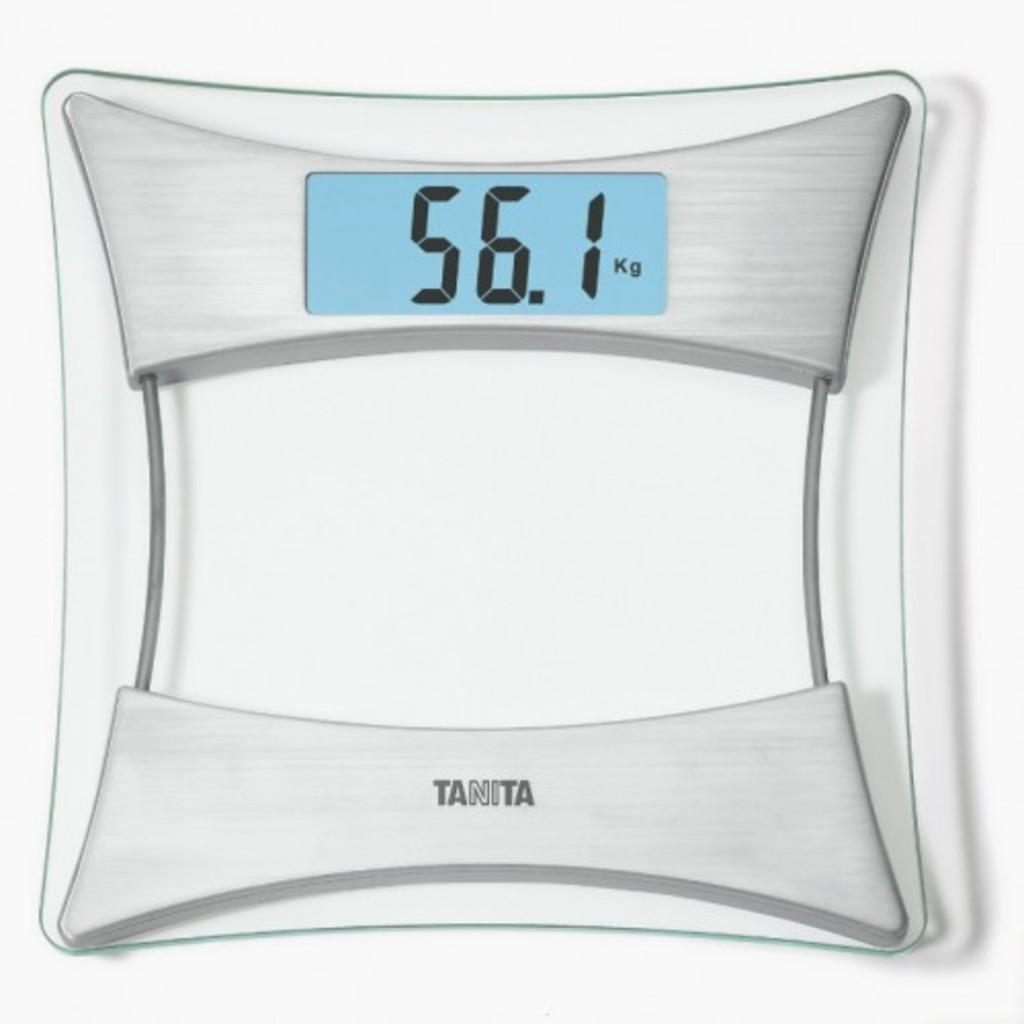What type of device is in the picture? There is a digital weighing scale in the picture. What color is the background of the image? The background of the image is white. What feature is present on the weighing scale for displaying information? There is an LED display screen on the weighing scale. Is there any branding or identification on the weighing scale? Yes, there is a logo at the bottom of the machine. What type of bait is being used to attract humor in the image? There is no bait or humor present in the image; it features a digital weighing scale with a white background. 